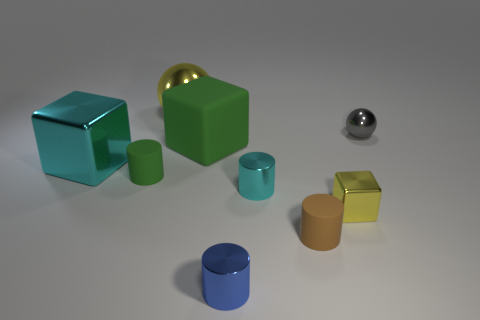Add 1 cyan cylinders. How many objects exist? 10 Subtract all balls. How many objects are left? 7 Subtract 0 blue blocks. How many objects are left? 9 Subtract all brown rubber objects. Subtract all large matte blocks. How many objects are left? 7 Add 4 small balls. How many small balls are left? 5 Add 7 large cyan cubes. How many large cyan cubes exist? 8 